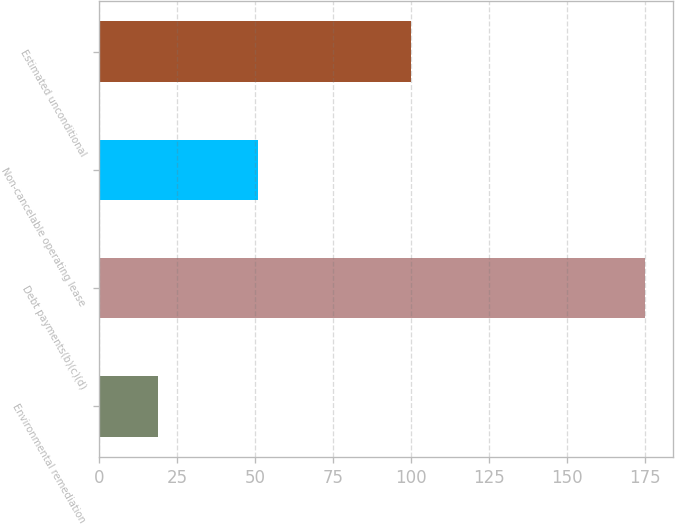<chart> <loc_0><loc_0><loc_500><loc_500><bar_chart><fcel>Environmental remediation<fcel>Debt payments(b)(c)(d)<fcel>Non-cancelable operating lease<fcel>Estimated unconditional<nl><fcel>19<fcel>175<fcel>51<fcel>100<nl></chart> 